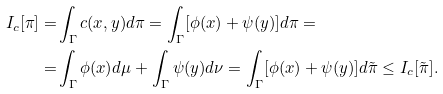<formula> <loc_0><loc_0><loc_500><loc_500>I _ { c } [ \pi ] = & \int _ { \Gamma } c ( x , y ) d \pi = \int _ { \Gamma } [ \phi ( x ) + \psi ( y ) ] d \pi = \\ = & \int _ { \Gamma } \phi ( x ) d \mu + \int _ { \Gamma } \psi ( y ) d \nu = \int _ { \Gamma } [ \phi ( x ) + \psi ( y ) ] d \tilde { \pi } \leq I _ { c } [ \tilde { \pi } ] .</formula> 